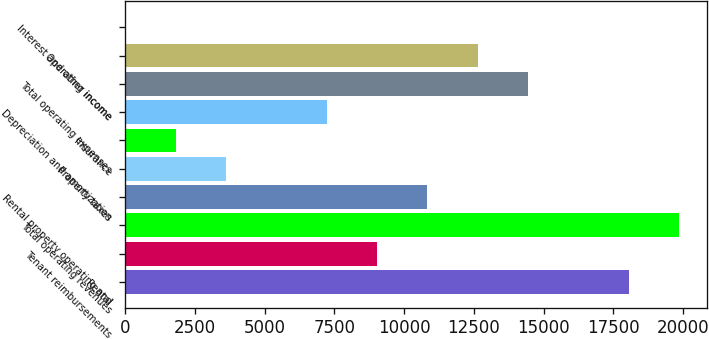Convert chart to OTSL. <chart><loc_0><loc_0><loc_500><loc_500><bar_chart><fcel>Rental<fcel>Tenant reimbursements<fcel>Total operating revenues<fcel>Rental property operating and<fcel>Property taxes<fcel>Insurance<fcel>Depreciation and amortization<fcel>Total operating expenses<fcel>Operating income<fcel>Interest and other income<nl><fcel>18049<fcel>9027<fcel>19853.4<fcel>10831.4<fcel>3613.8<fcel>1809.4<fcel>7222.6<fcel>14440.2<fcel>12635.8<fcel>5<nl></chart> 